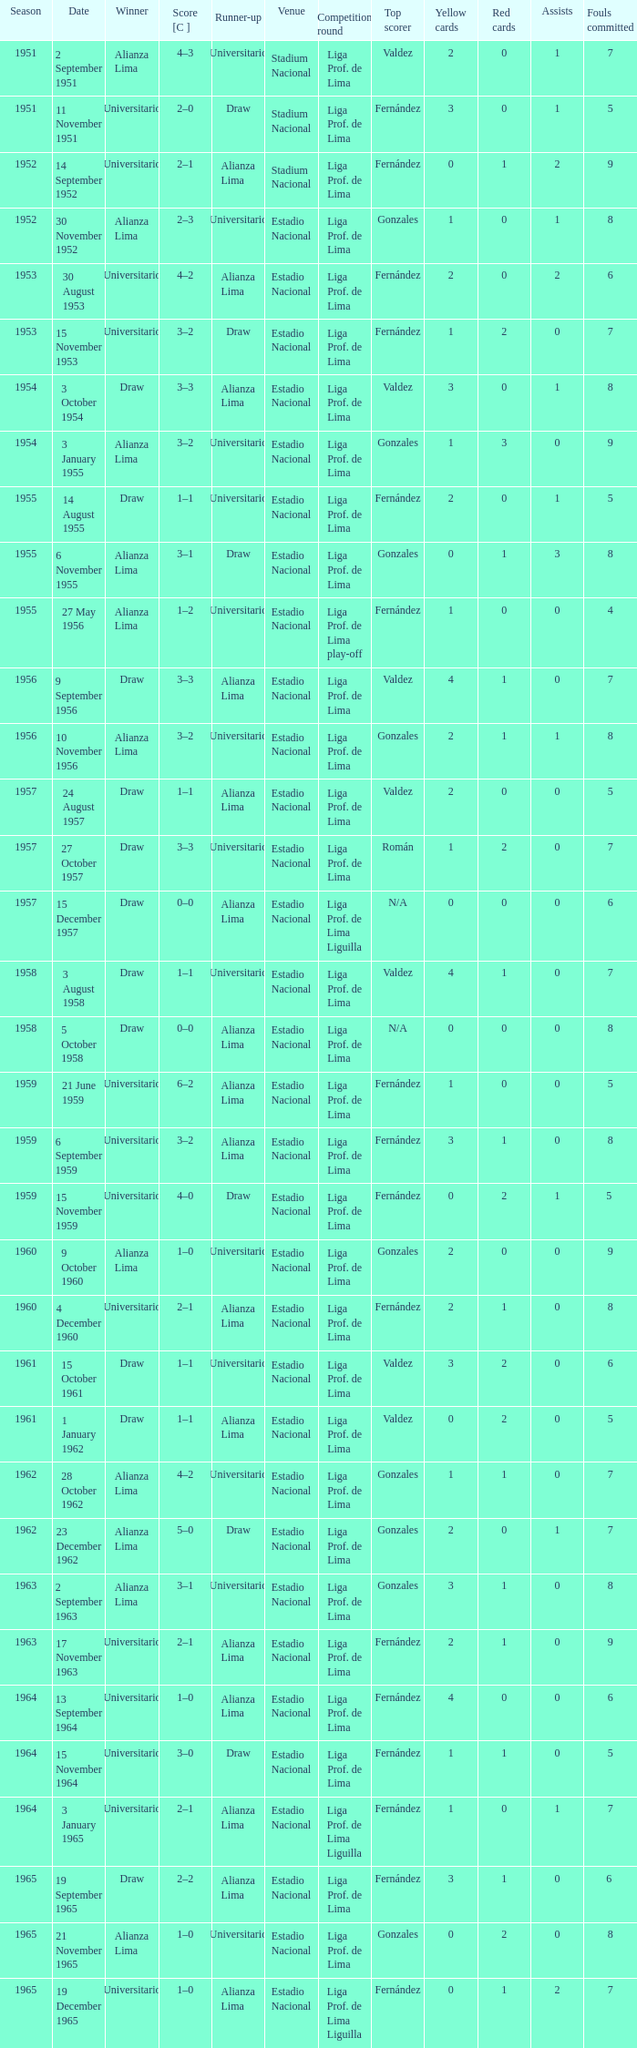What is the score of the event that Alianza Lima won in 1965? 1–0. 